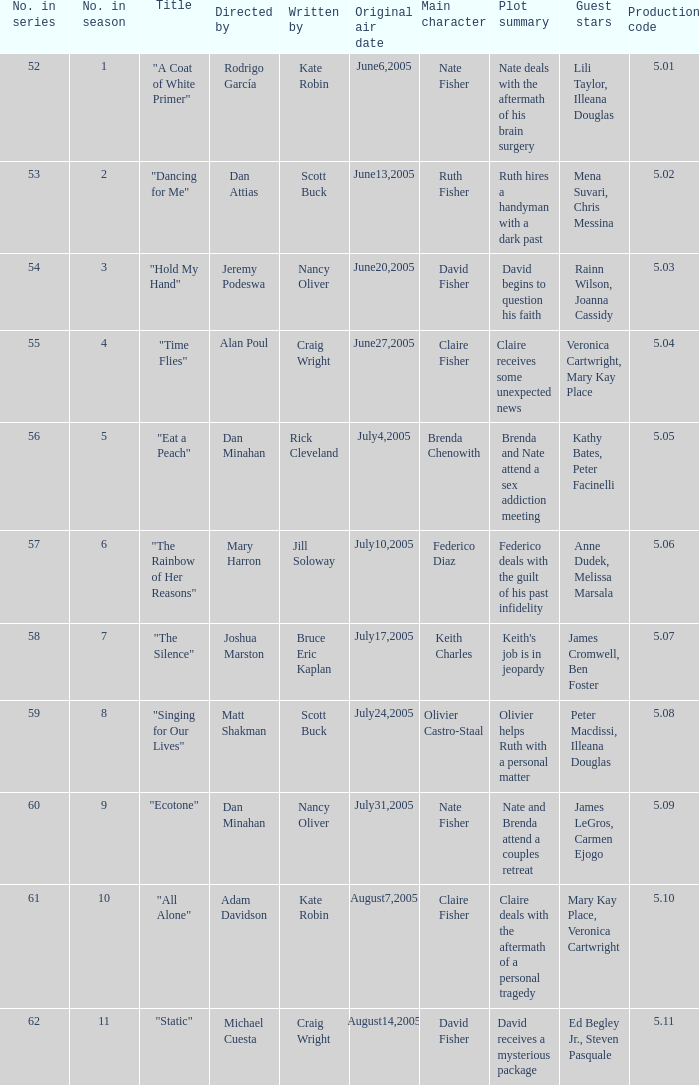Could you help me parse every detail presented in this table? {'header': ['No. in series', 'No. in season', 'Title', 'Directed by', 'Written by', 'Original air date', 'Main character', 'Plot summary', 'Guest stars', 'Production code'], 'rows': [['52', '1', '"A Coat of White Primer"', 'Rodrigo García', 'Kate Robin', 'June6,2005', 'Nate Fisher', 'Nate deals with the aftermath of his brain surgery', 'Lili Taylor, Illeana Douglas', '5.01'], ['53', '2', '"Dancing for Me"', 'Dan Attias', 'Scott Buck', 'June13,2005', 'Ruth Fisher', 'Ruth hires a handyman with a dark past', 'Mena Suvari, Chris Messina', '5.02'], ['54', '3', '"Hold My Hand"', 'Jeremy Podeswa', 'Nancy Oliver', 'June20,2005', 'David Fisher', 'David begins to question his faith', 'Rainn Wilson, Joanna Cassidy', '5.03'], ['55', '4', '"Time Flies"', 'Alan Poul', 'Craig Wright', 'June27,2005', 'Claire Fisher', 'Claire receives some unexpected news', 'Veronica Cartwright, Mary Kay Place', '5.04'], ['56', '5', '"Eat a Peach"', 'Dan Minahan', 'Rick Cleveland', 'July4,2005', 'Brenda Chenowith', 'Brenda and Nate attend a sex addiction meeting', 'Kathy Bates, Peter Facinelli', '5.05'], ['57', '6', '"The Rainbow of Her Reasons"', 'Mary Harron', 'Jill Soloway', 'July10,2005', 'Federico Diaz', 'Federico deals with the guilt of his past infidelity', 'Anne Dudek, Melissa Marsala', '5.06'], ['58', '7', '"The Silence"', 'Joshua Marston', 'Bruce Eric Kaplan', 'July17,2005', 'Keith Charles', "Keith's job is in jeopardy", 'James Cromwell, Ben Foster', '5.07'], ['59', '8', '"Singing for Our Lives"', 'Matt Shakman', 'Scott Buck', 'July24,2005', 'Olivier Castro-Staal', 'Olivier helps Ruth with a personal matter', 'Peter Macdissi, Illeana Douglas', '5.08'], ['60', '9', '"Ecotone"', 'Dan Minahan', 'Nancy Oliver', 'July31,2005', 'Nate Fisher', 'Nate and Brenda attend a couples retreat', 'James LeGros, Carmen Ejogo', '5.09'], ['61', '10', '"All Alone"', 'Adam Davidson', 'Kate Robin', 'August7,2005', 'Claire Fisher', 'Claire deals with the aftermath of a personal tragedy', 'Mary Kay Place, Veronica Cartwright', '5.10'], ['62', '11', '"Static"', 'Michael Cuesta', 'Craig Wright', 'August14,2005', 'David Fisher', 'David receives a mysterious package', 'Ed Begley Jr., Steven Pasquale', '5.11']]} What was the name of the episode that was directed by Mary Harron? "The Rainbow of Her Reasons". 